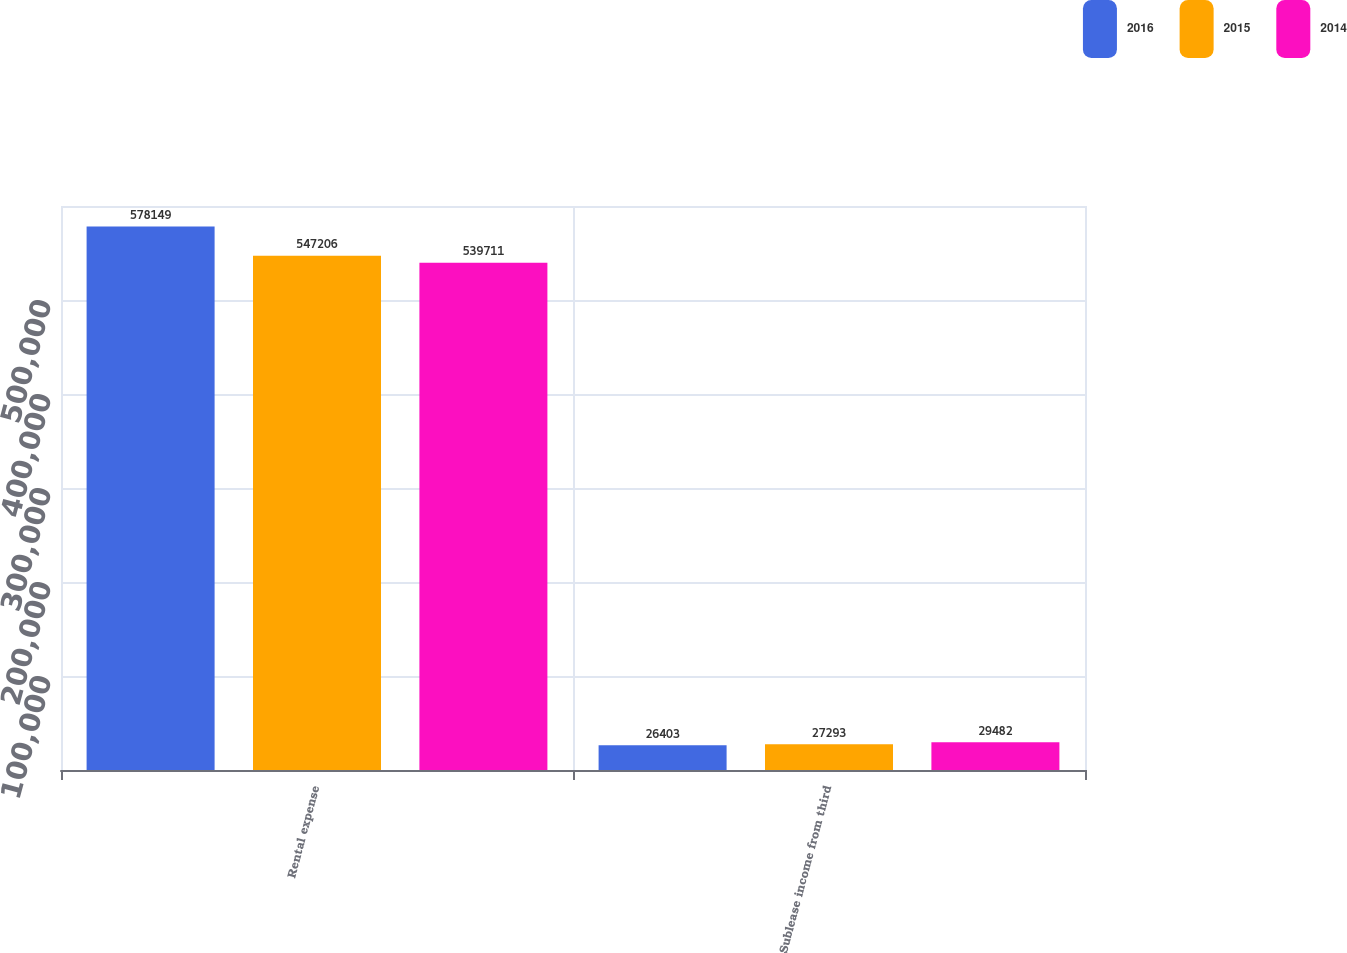Convert chart to OTSL. <chart><loc_0><loc_0><loc_500><loc_500><stacked_bar_chart><ecel><fcel>Rental expense<fcel>Sublease income from third<nl><fcel>2016<fcel>578149<fcel>26403<nl><fcel>2015<fcel>547206<fcel>27293<nl><fcel>2014<fcel>539711<fcel>29482<nl></chart> 